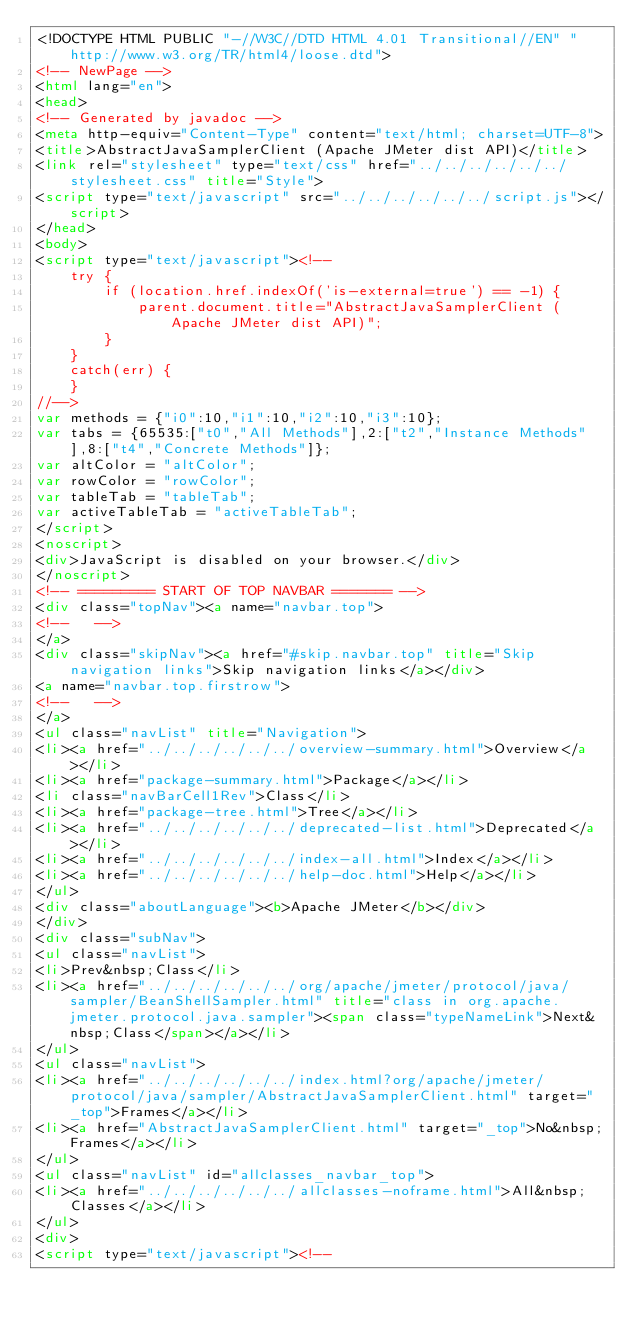<code> <loc_0><loc_0><loc_500><loc_500><_HTML_><!DOCTYPE HTML PUBLIC "-//W3C//DTD HTML 4.01 Transitional//EN" "http://www.w3.org/TR/html4/loose.dtd">
<!-- NewPage -->
<html lang="en">
<head>
<!-- Generated by javadoc -->
<meta http-equiv="Content-Type" content="text/html; charset=UTF-8">
<title>AbstractJavaSamplerClient (Apache JMeter dist API)</title>
<link rel="stylesheet" type="text/css" href="../../../../../../stylesheet.css" title="Style">
<script type="text/javascript" src="../../../../../../script.js"></script>
</head>
<body>
<script type="text/javascript"><!--
    try {
        if (location.href.indexOf('is-external=true') == -1) {
            parent.document.title="AbstractJavaSamplerClient (Apache JMeter dist API)";
        }
    }
    catch(err) {
    }
//-->
var methods = {"i0":10,"i1":10,"i2":10,"i3":10};
var tabs = {65535:["t0","All Methods"],2:["t2","Instance Methods"],8:["t4","Concrete Methods"]};
var altColor = "altColor";
var rowColor = "rowColor";
var tableTab = "tableTab";
var activeTableTab = "activeTableTab";
</script>
<noscript>
<div>JavaScript is disabled on your browser.</div>
</noscript>
<!-- ========= START OF TOP NAVBAR ======= -->
<div class="topNav"><a name="navbar.top">
<!--   -->
</a>
<div class="skipNav"><a href="#skip.navbar.top" title="Skip navigation links">Skip navigation links</a></div>
<a name="navbar.top.firstrow">
<!--   -->
</a>
<ul class="navList" title="Navigation">
<li><a href="../../../../../../overview-summary.html">Overview</a></li>
<li><a href="package-summary.html">Package</a></li>
<li class="navBarCell1Rev">Class</li>
<li><a href="package-tree.html">Tree</a></li>
<li><a href="../../../../../../deprecated-list.html">Deprecated</a></li>
<li><a href="../../../../../../index-all.html">Index</a></li>
<li><a href="../../../../../../help-doc.html">Help</a></li>
</ul>
<div class="aboutLanguage"><b>Apache JMeter</b></div>
</div>
<div class="subNav">
<ul class="navList">
<li>Prev&nbsp;Class</li>
<li><a href="../../../../../../org/apache/jmeter/protocol/java/sampler/BeanShellSampler.html" title="class in org.apache.jmeter.protocol.java.sampler"><span class="typeNameLink">Next&nbsp;Class</span></a></li>
</ul>
<ul class="navList">
<li><a href="../../../../../../index.html?org/apache/jmeter/protocol/java/sampler/AbstractJavaSamplerClient.html" target="_top">Frames</a></li>
<li><a href="AbstractJavaSamplerClient.html" target="_top">No&nbsp;Frames</a></li>
</ul>
<ul class="navList" id="allclasses_navbar_top">
<li><a href="../../../../../../allclasses-noframe.html">All&nbsp;Classes</a></li>
</ul>
<div>
<script type="text/javascript"><!--</code> 